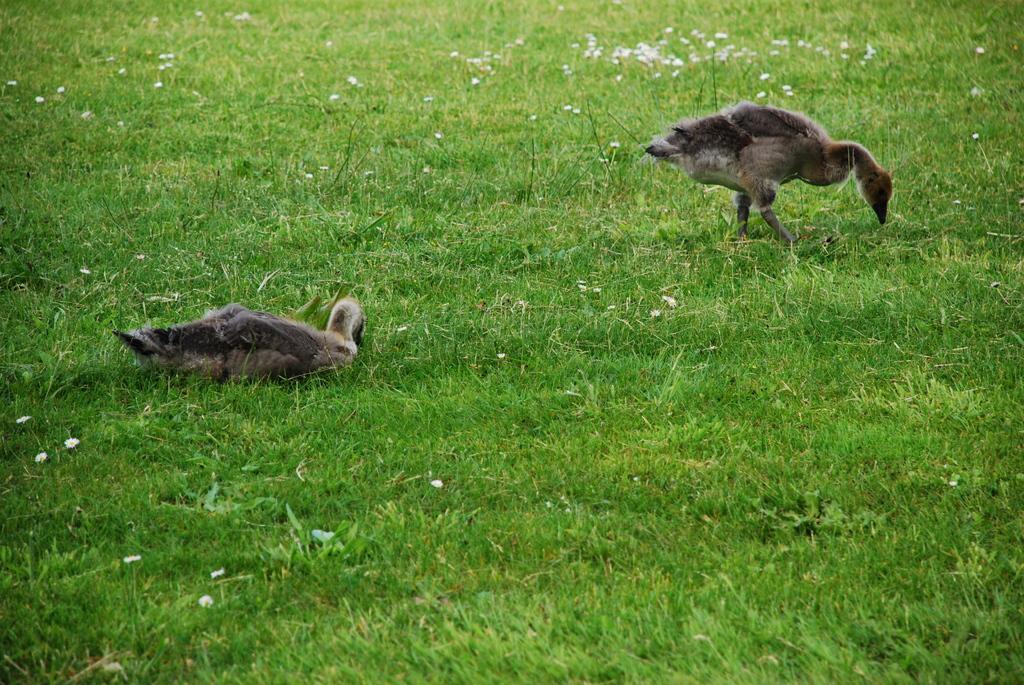Can you describe this image briefly? In this picture we can see two birds and grass are present. 